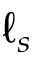<formula> <loc_0><loc_0><loc_500><loc_500>\ell _ { s }</formula> 